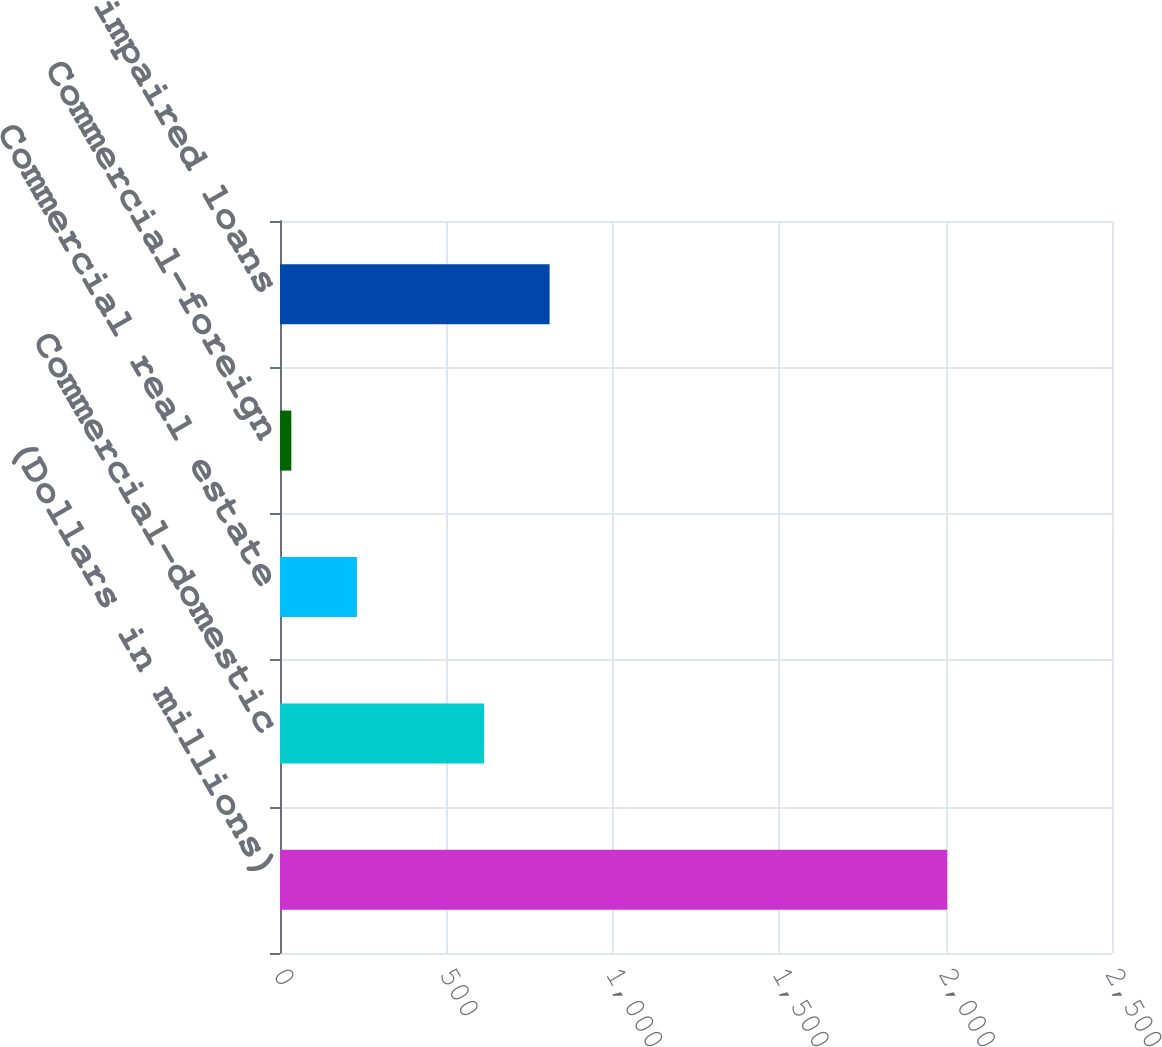Convert chart to OTSL. <chart><loc_0><loc_0><loc_500><loc_500><bar_chart><fcel>(Dollars in millions)<fcel>Commercial-domestic<fcel>Commercial real estate<fcel>Commercial-foreign<fcel>Total impaired loans<nl><fcel>2005<fcel>613<fcel>231.1<fcel>34<fcel>810.1<nl></chart> 